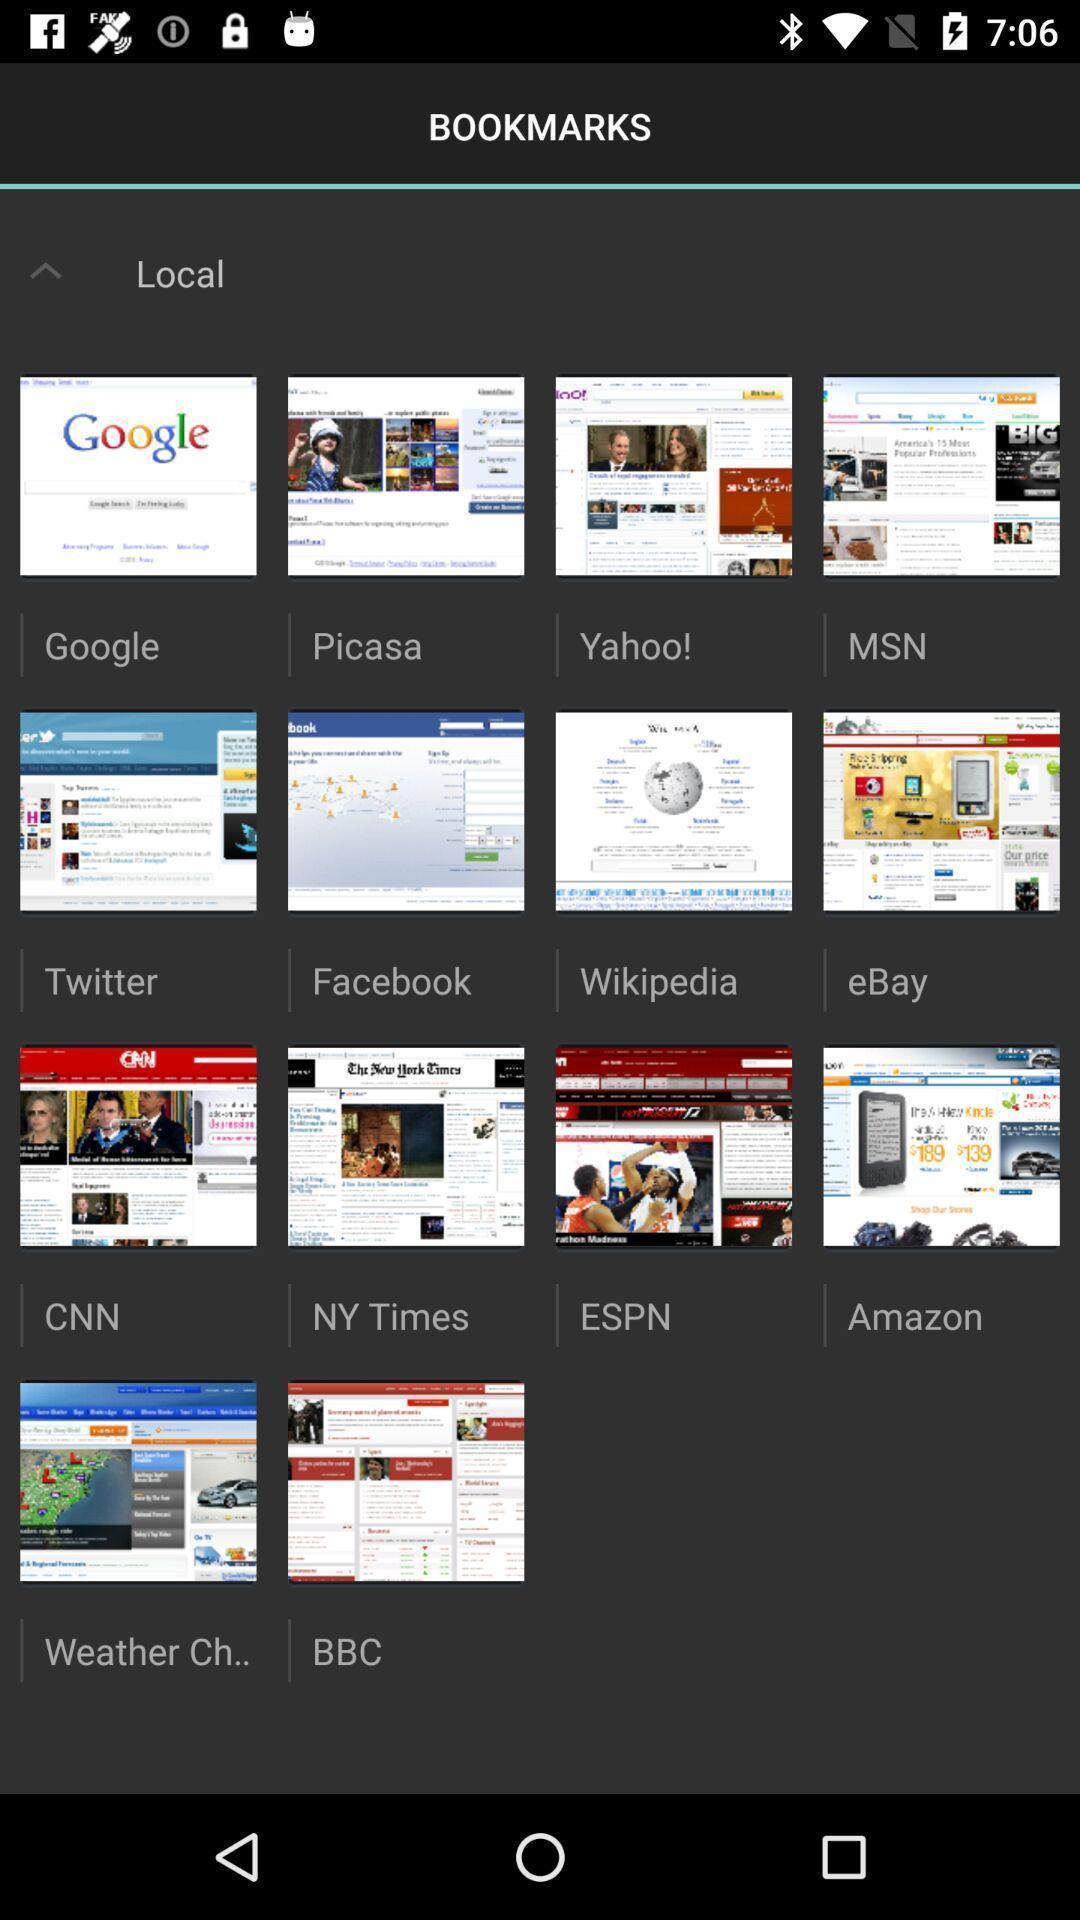Please provide a description for this image. Screen showing bookmarks. 